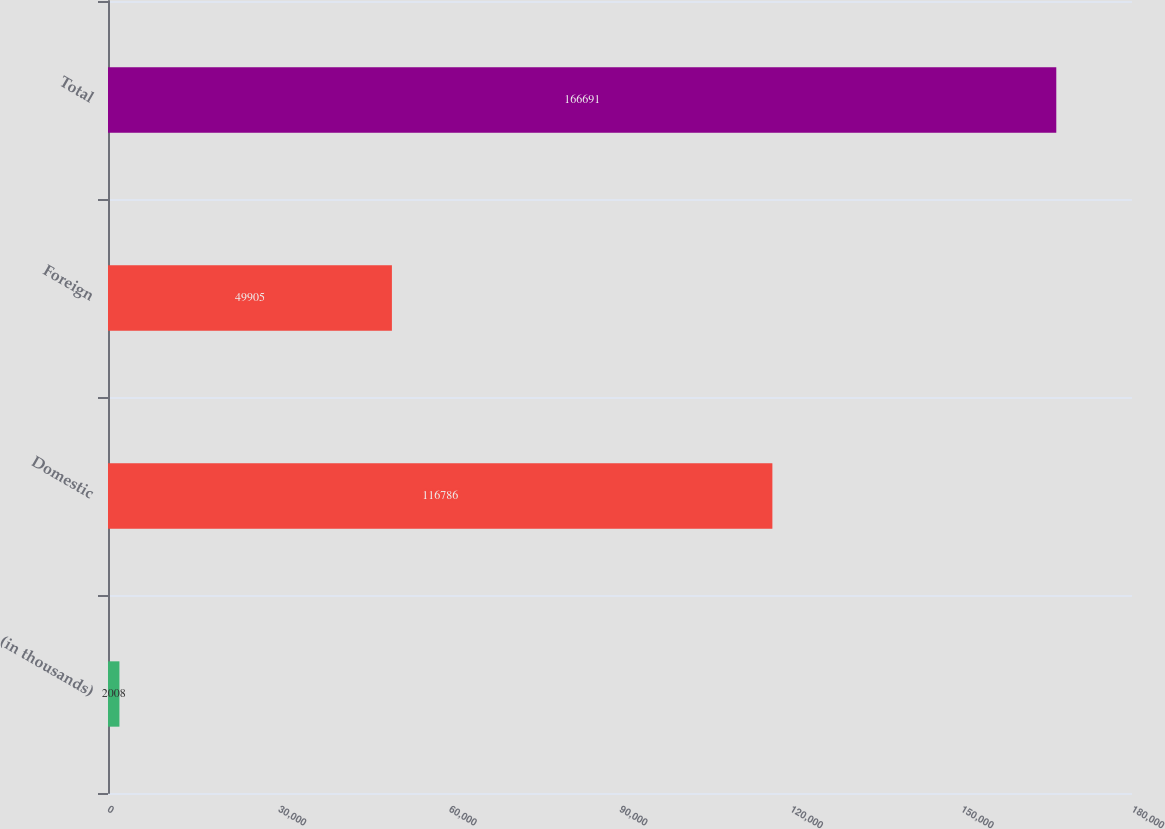<chart> <loc_0><loc_0><loc_500><loc_500><bar_chart><fcel>(in thousands)<fcel>Domestic<fcel>Foreign<fcel>Total<nl><fcel>2008<fcel>116786<fcel>49905<fcel>166691<nl></chart> 